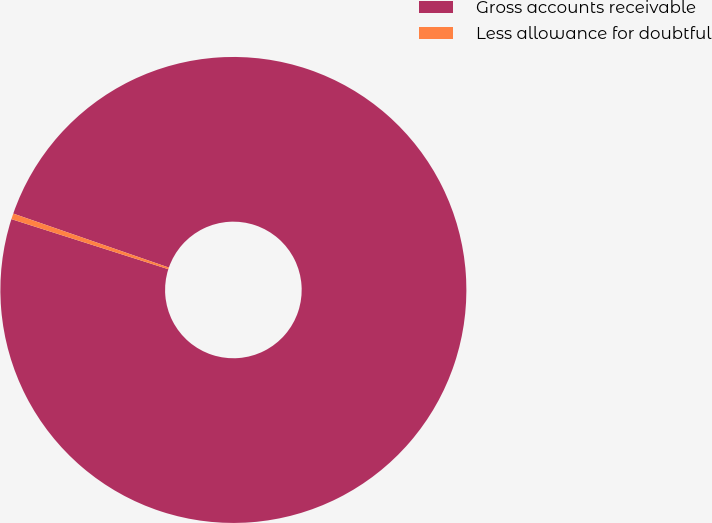Convert chart. <chart><loc_0><loc_0><loc_500><loc_500><pie_chart><fcel>Gross accounts receivable<fcel>Less allowance for doubtful<nl><fcel>99.6%<fcel>0.4%<nl></chart> 